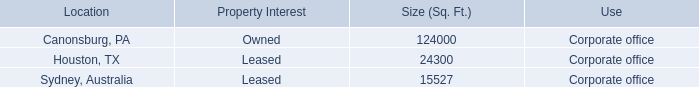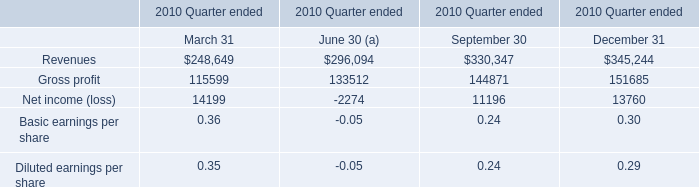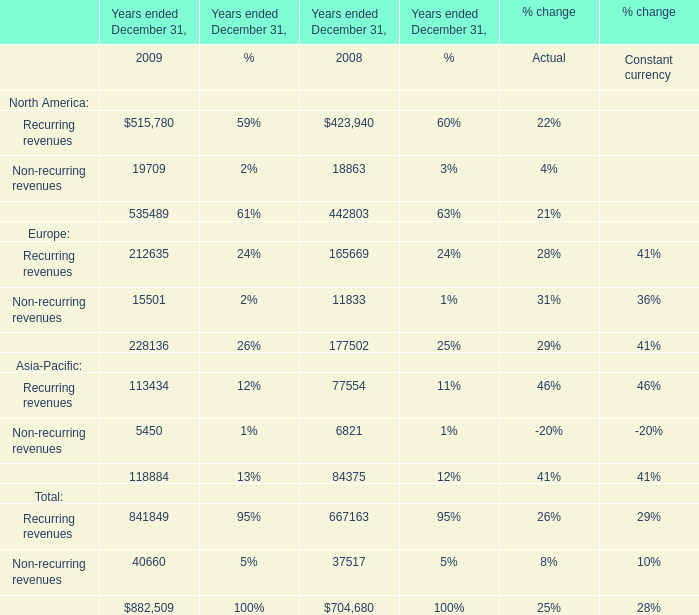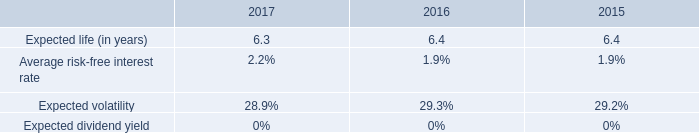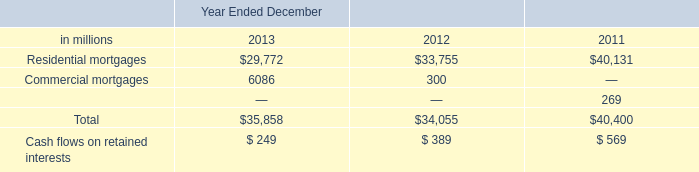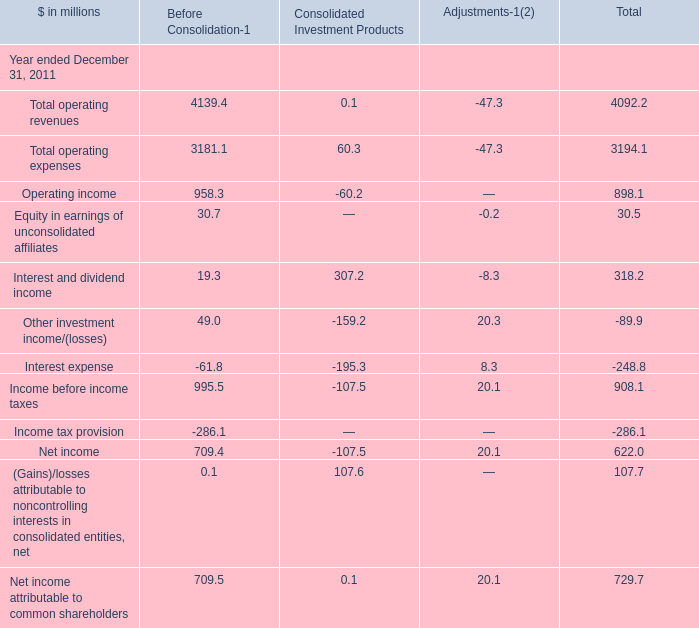What is the total amount of Gross profit of 2010 Quarter ended March 31, Commercial mortgages of Year Ended December 2013, and Recurring revenues of Years ended December 31, 2008 ? 
Computations: ((115599.0 + 6086.0) + 423940.0)
Answer: 545625.0. 